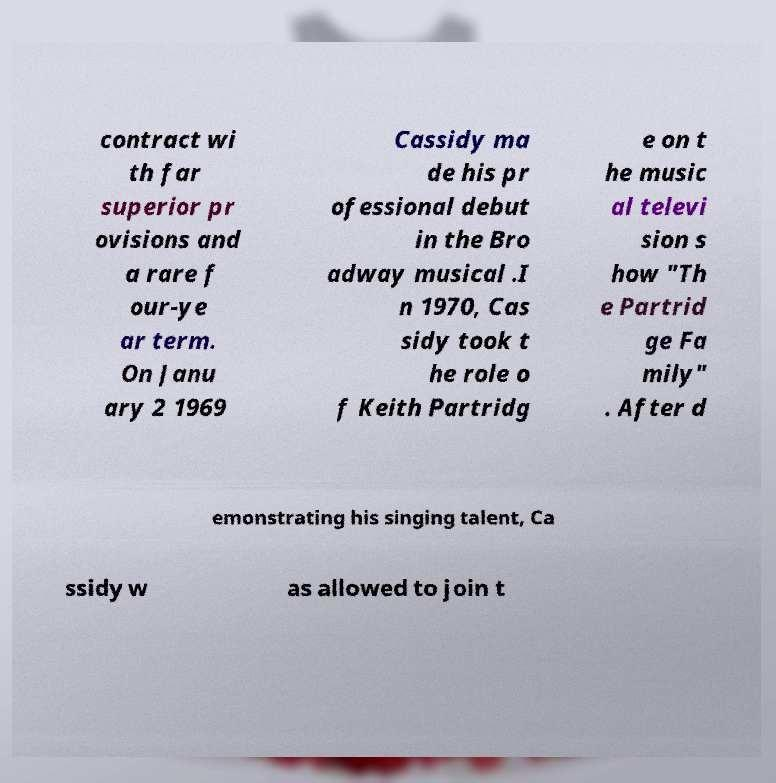Please read and relay the text visible in this image. What does it say? contract wi th far superior pr ovisions and a rare f our-ye ar term. On Janu ary 2 1969 Cassidy ma de his pr ofessional debut in the Bro adway musical .I n 1970, Cas sidy took t he role o f Keith Partridg e on t he music al televi sion s how "Th e Partrid ge Fa mily" . After d emonstrating his singing talent, Ca ssidy w as allowed to join t 